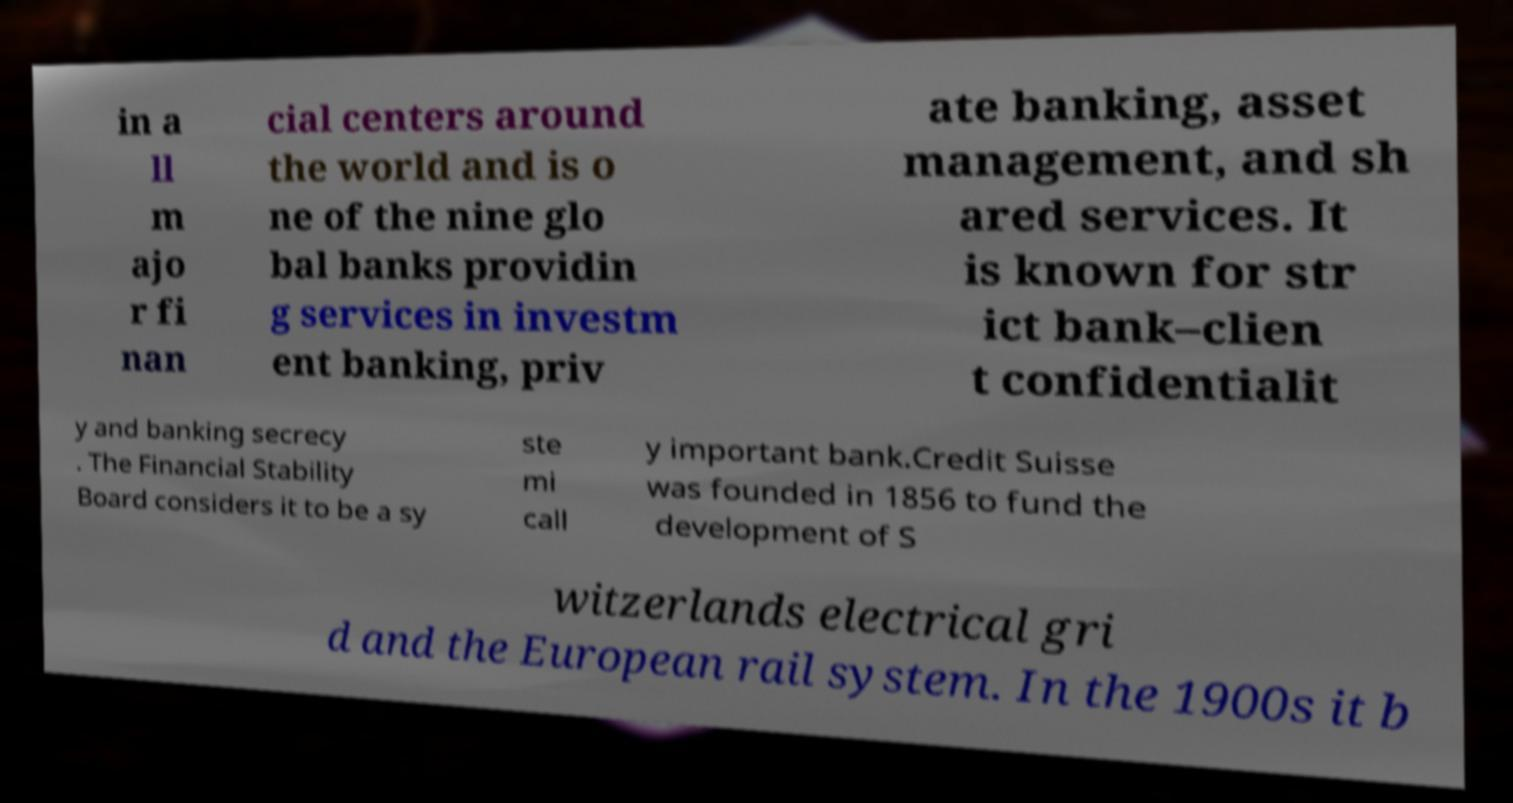Could you extract and type out the text from this image? in a ll m ajo r fi nan cial centers around the world and is o ne of the nine glo bal banks providin g services in investm ent banking, priv ate banking, asset management, and sh ared services. It is known for str ict bank–clien t confidentialit y and banking secrecy . The Financial Stability Board considers it to be a sy ste mi call y important bank.Credit Suisse was founded in 1856 to fund the development of S witzerlands electrical gri d and the European rail system. In the 1900s it b 